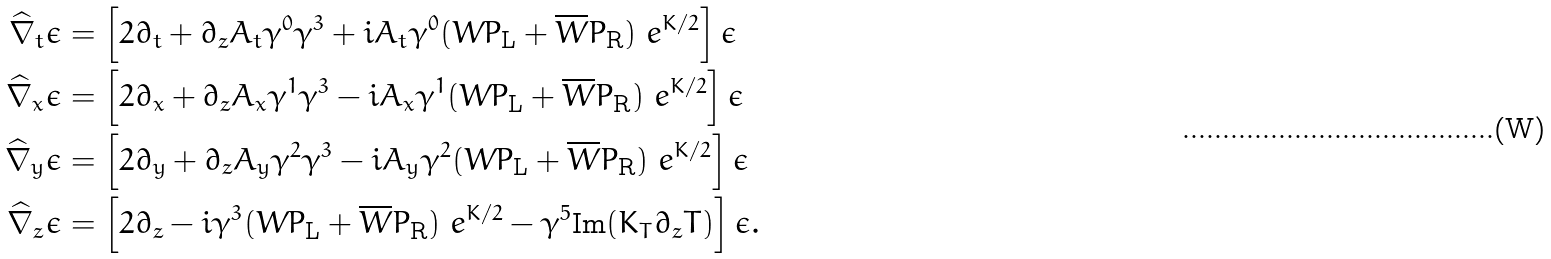<formula> <loc_0><loc_0><loc_500><loc_500>\widehat { \nabla } _ { t } \epsilon & = \left [ 2 \partial _ { t } + \partial _ { z } A _ { t } \gamma ^ { 0 } \gamma ^ { 3 } + i A _ { t } \gamma ^ { 0 } ( W P _ { \text {L} } + \overline { W } P _ { \text {R} } ) \ e ^ { K / 2 } \right ] \epsilon \\ \widehat { \nabla } _ { x } \epsilon & = \left [ 2 \partial _ { x } + \partial _ { z } A _ { x } \gamma ^ { 1 } \gamma ^ { 3 } - i A _ { x } \gamma ^ { 1 } ( W P _ { \text {L} } + \overline { W } P _ { \text {R} } ) \ e ^ { K / 2 } \right ] \epsilon \\ \widehat { \nabla } _ { y } \epsilon & = \left [ 2 \partial _ { y } + \partial _ { z } A _ { y } \gamma ^ { 2 } \gamma ^ { 3 } - i A _ { y } \gamma ^ { 2 } ( W P _ { \text {L} } + \overline { W } P _ { \text {R} } ) \ e ^ { K / 2 } \right ] \epsilon \\ \widehat { \nabla } _ { z } \epsilon & = \left [ 2 \partial _ { z } - i \gamma ^ { 3 } ( W P _ { \text {L} } + \overline { W } P _ { \text {R} } ) \ e ^ { K / 2 } - \gamma ^ { 5 } \text {Im} ( K _ { T } \partial _ { z } T ) \right ] \epsilon .</formula> 